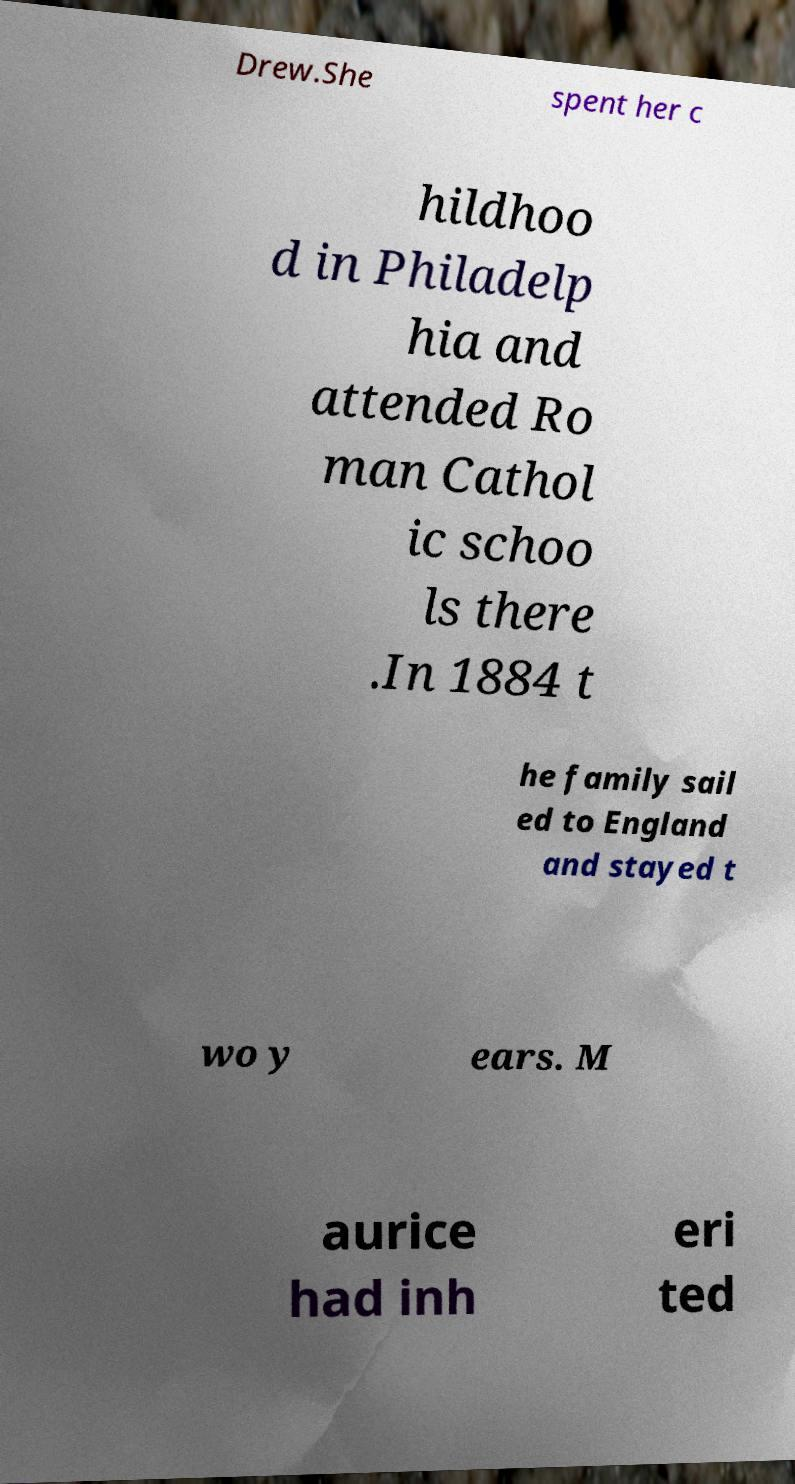Could you extract and type out the text from this image? Drew.She spent her c hildhoo d in Philadelp hia and attended Ro man Cathol ic schoo ls there .In 1884 t he family sail ed to England and stayed t wo y ears. M aurice had inh eri ted 